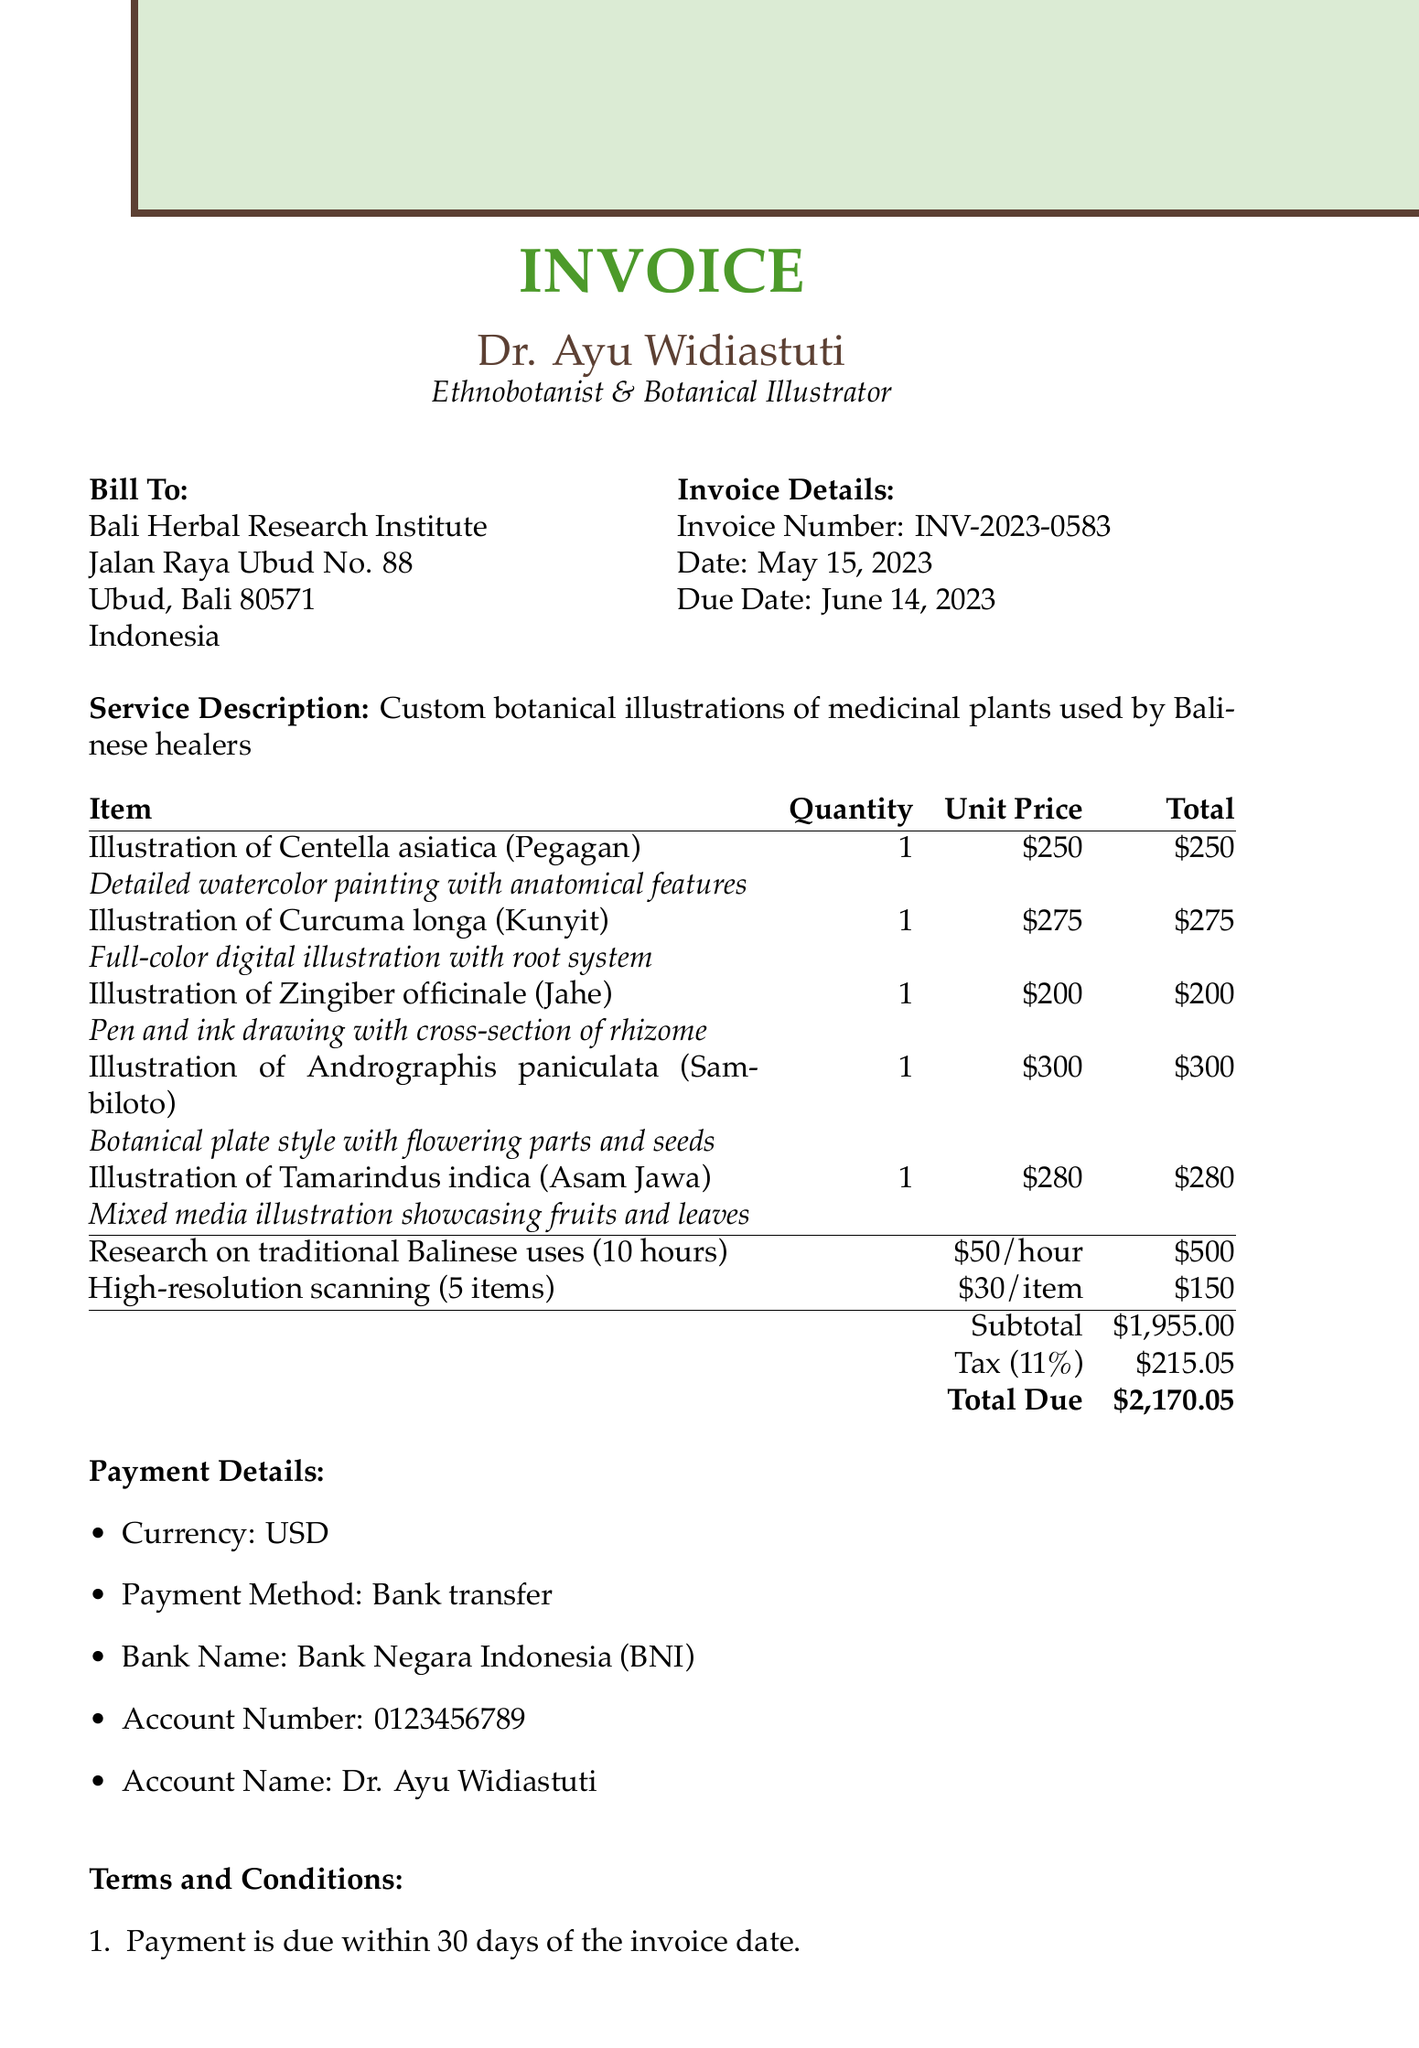what is the invoice number? The invoice number is specifically stated in the document for reference as "INV-2023-0583".
Answer: INV-2023-0583 what is the total amount due? The document clearly states the total amount due at the bottom of the payment details.
Answer: $2,170.05 who is the client for this invoice? The client's name is mentioned at the beginning of the document in the billing section.
Answer: Bali Herbal Research Institute how many illustrations are listed in the invoice? The itemized costs section counts the individual items, which are the illustrations requested.
Answer: 5 what is the tax rate applied to the invoice? The tax rate is specified as a percentage in the payment details of the document.
Answer: 11% what is the main service provided as per the invoice? The document describes the service offered which is listed prominently in the service description section.
Answer: Custom botanical illustrations of medicinal plants used by Balinese healers what is the payment method mentioned in the invoice? The payment method utilized for this invoice is clearly outlined in the payment details section.
Answer: Bank transfer how many hours were spent on research according to the invoice? The additional services section specifies the hours allocated for research on traditional uses.
Answer: 10 what does the note at the end of the invoice express? The note summarizes the aim and appreciation for the collaboration on the project concerning traditional Balinese knowledge.
Answer: Thank you for your collaboration on this project to document and preserve traditional Balinese medicinal plant knowledge 